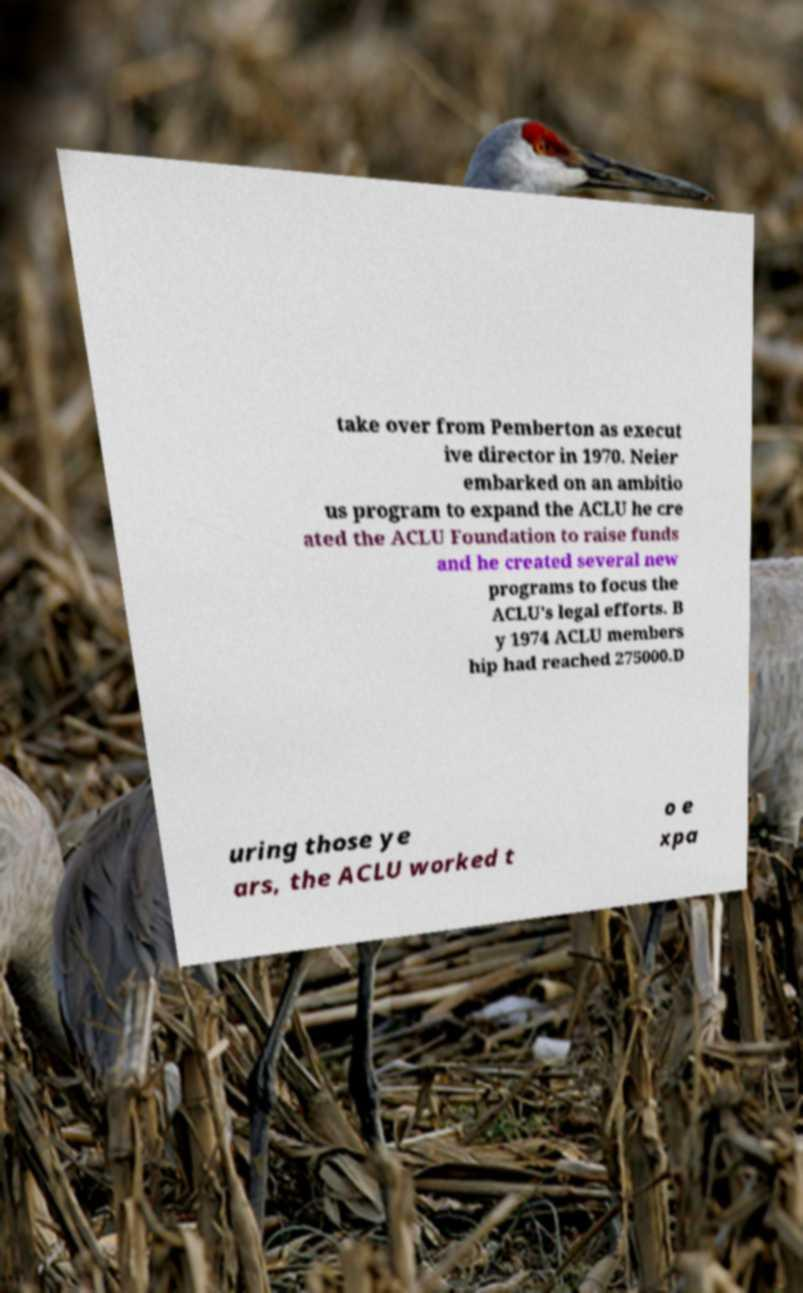Please identify and transcribe the text found in this image. take over from Pemberton as execut ive director in 1970. Neier embarked on an ambitio us program to expand the ACLU he cre ated the ACLU Foundation to raise funds and he created several new programs to focus the ACLU's legal efforts. B y 1974 ACLU members hip had reached 275000.D uring those ye ars, the ACLU worked t o e xpa 